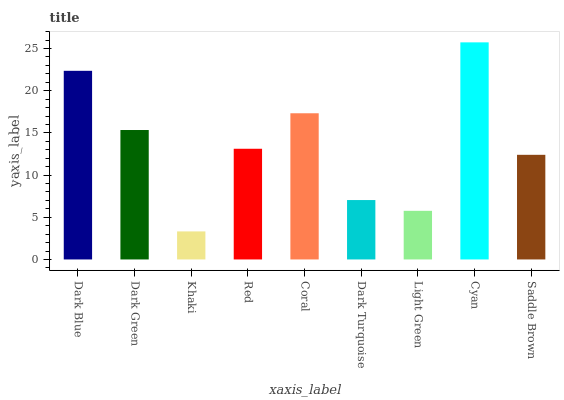Is Khaki the minimum?
Answer yes or no. Yes. Is Cyan the maximum?
Answer yes or no. Yes. Is Dark Green the minimum?
Answer yes or no. No. Is Dark Green the maximum?
Answer yes or no. No. Is Dark Blue greater than Dark Green?
Answer yes or no. Yes. Is Dark Green less than Dark Blue?
Answer yes or no. Yes. Is Dark Green greater than Dark Blue?
Answer yes or no. No. Is Dark Blue less than Dark Green?
Answer yes or no. No. Is Red the high median?
Answer yes or no. Yes. Is Red the low median?
Answer yes or no. Yes. Is Cyan the high median?
Answer yes or no. No. Is Dark Blue the low median?
Answer yes or no. No. 